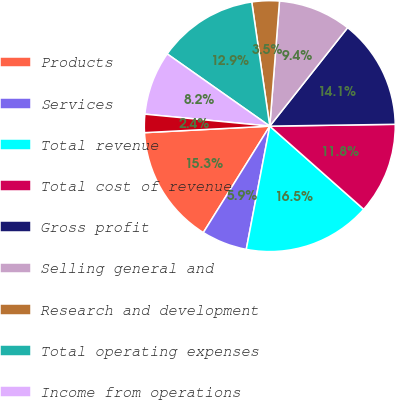Convert chart to OTSL. <chart><loc_0><loc_0><loc_500><loc_500><pie_chart><fcel>Products<fcel>Services<fcel>Total revenue<fcel>Total cost of revenue<fcel>Gross profit<fcel>Selling general and<fcel>Research and development<fcel>Total operating expenses<fcel>Income from operations<fcel>Interest and other income net<nl><fcel>15.29%<fcel>5.88%<fcel>16.47%<fcel>11.76%<fcel>14.12%<fcel>9.41%<fcel>3.53%<fcel>12.94%<fcel>8.24%<fcel>2.35%<nl></chart> 